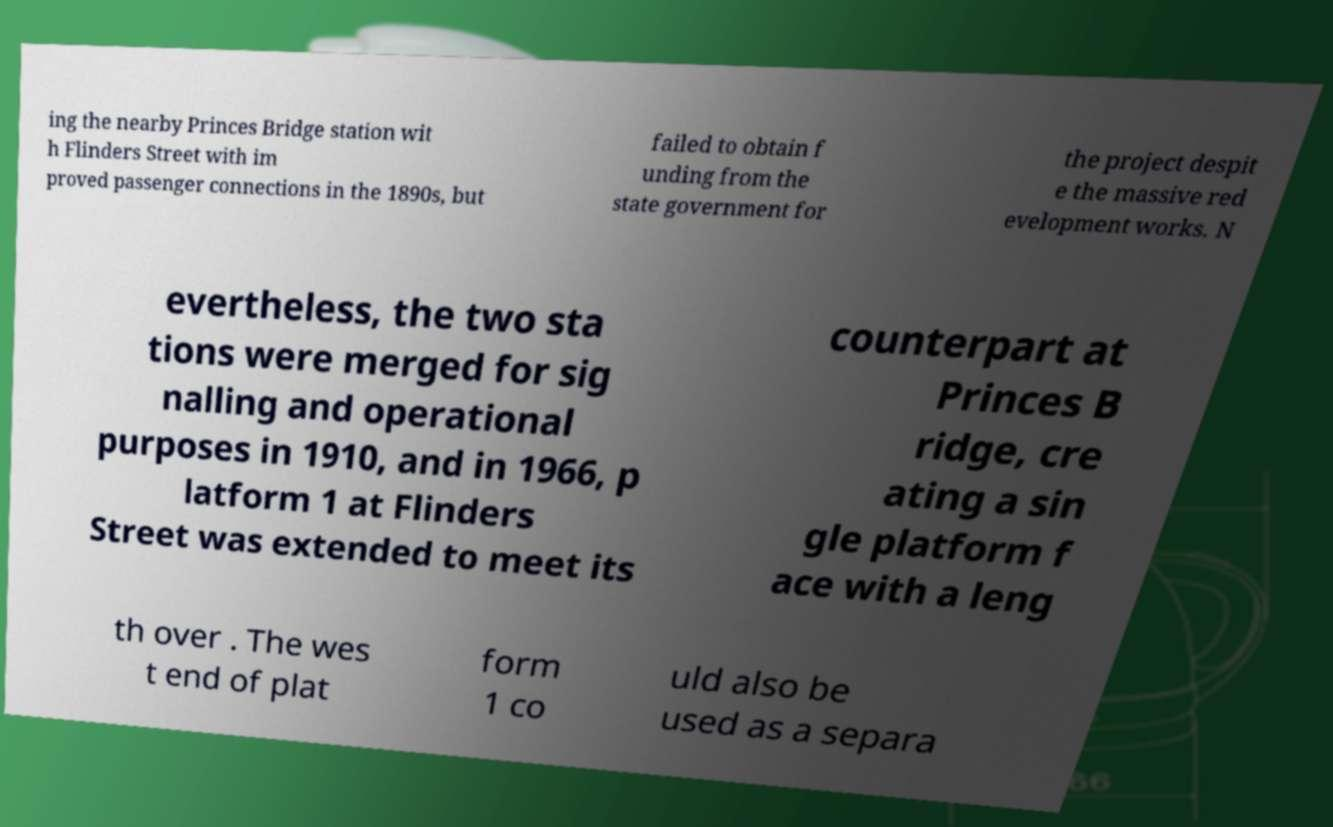Please identify and transcribe the text found in this image. ing the nearby Princes Bridge station wit h Flinders Street with im proved passenger connections in the 1890s, but failed to obtain f unding from the state government for the project despit e the massive red evelopment works. N evertheless, the two sta tions were merged for sig nalling and operational purposes in 1910, and in 1966, p latform 1 at Flinders Street was extended to meet its counterpart at Princes B ridge, cre ating a sin gle platform f ace with a leng th over . The wes t end of plat form 1 co uld also be used as a separa 